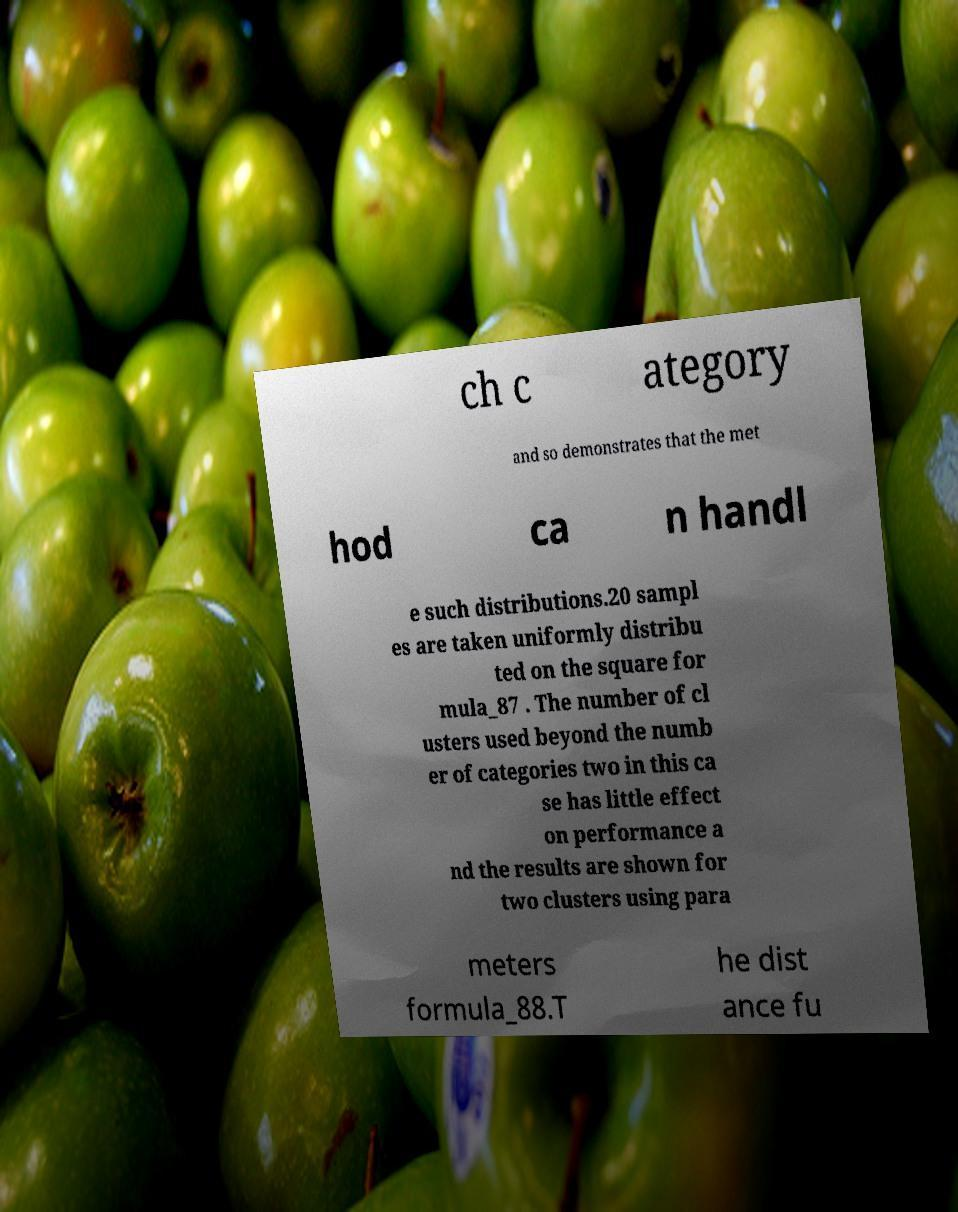I need the written content from this picture converted into text. Can you do that? ch c ategory and so demonstrates that the met hod ca n handl e such distributions.20 sampl es are taken uniformly distribu ted on the square for mula_87 . The number of cl usters used beyond the numb er of categories two in this ca se has little effect on performance a nd the results are shown for two clusters using para meters formula_88.T he dist ance fu 